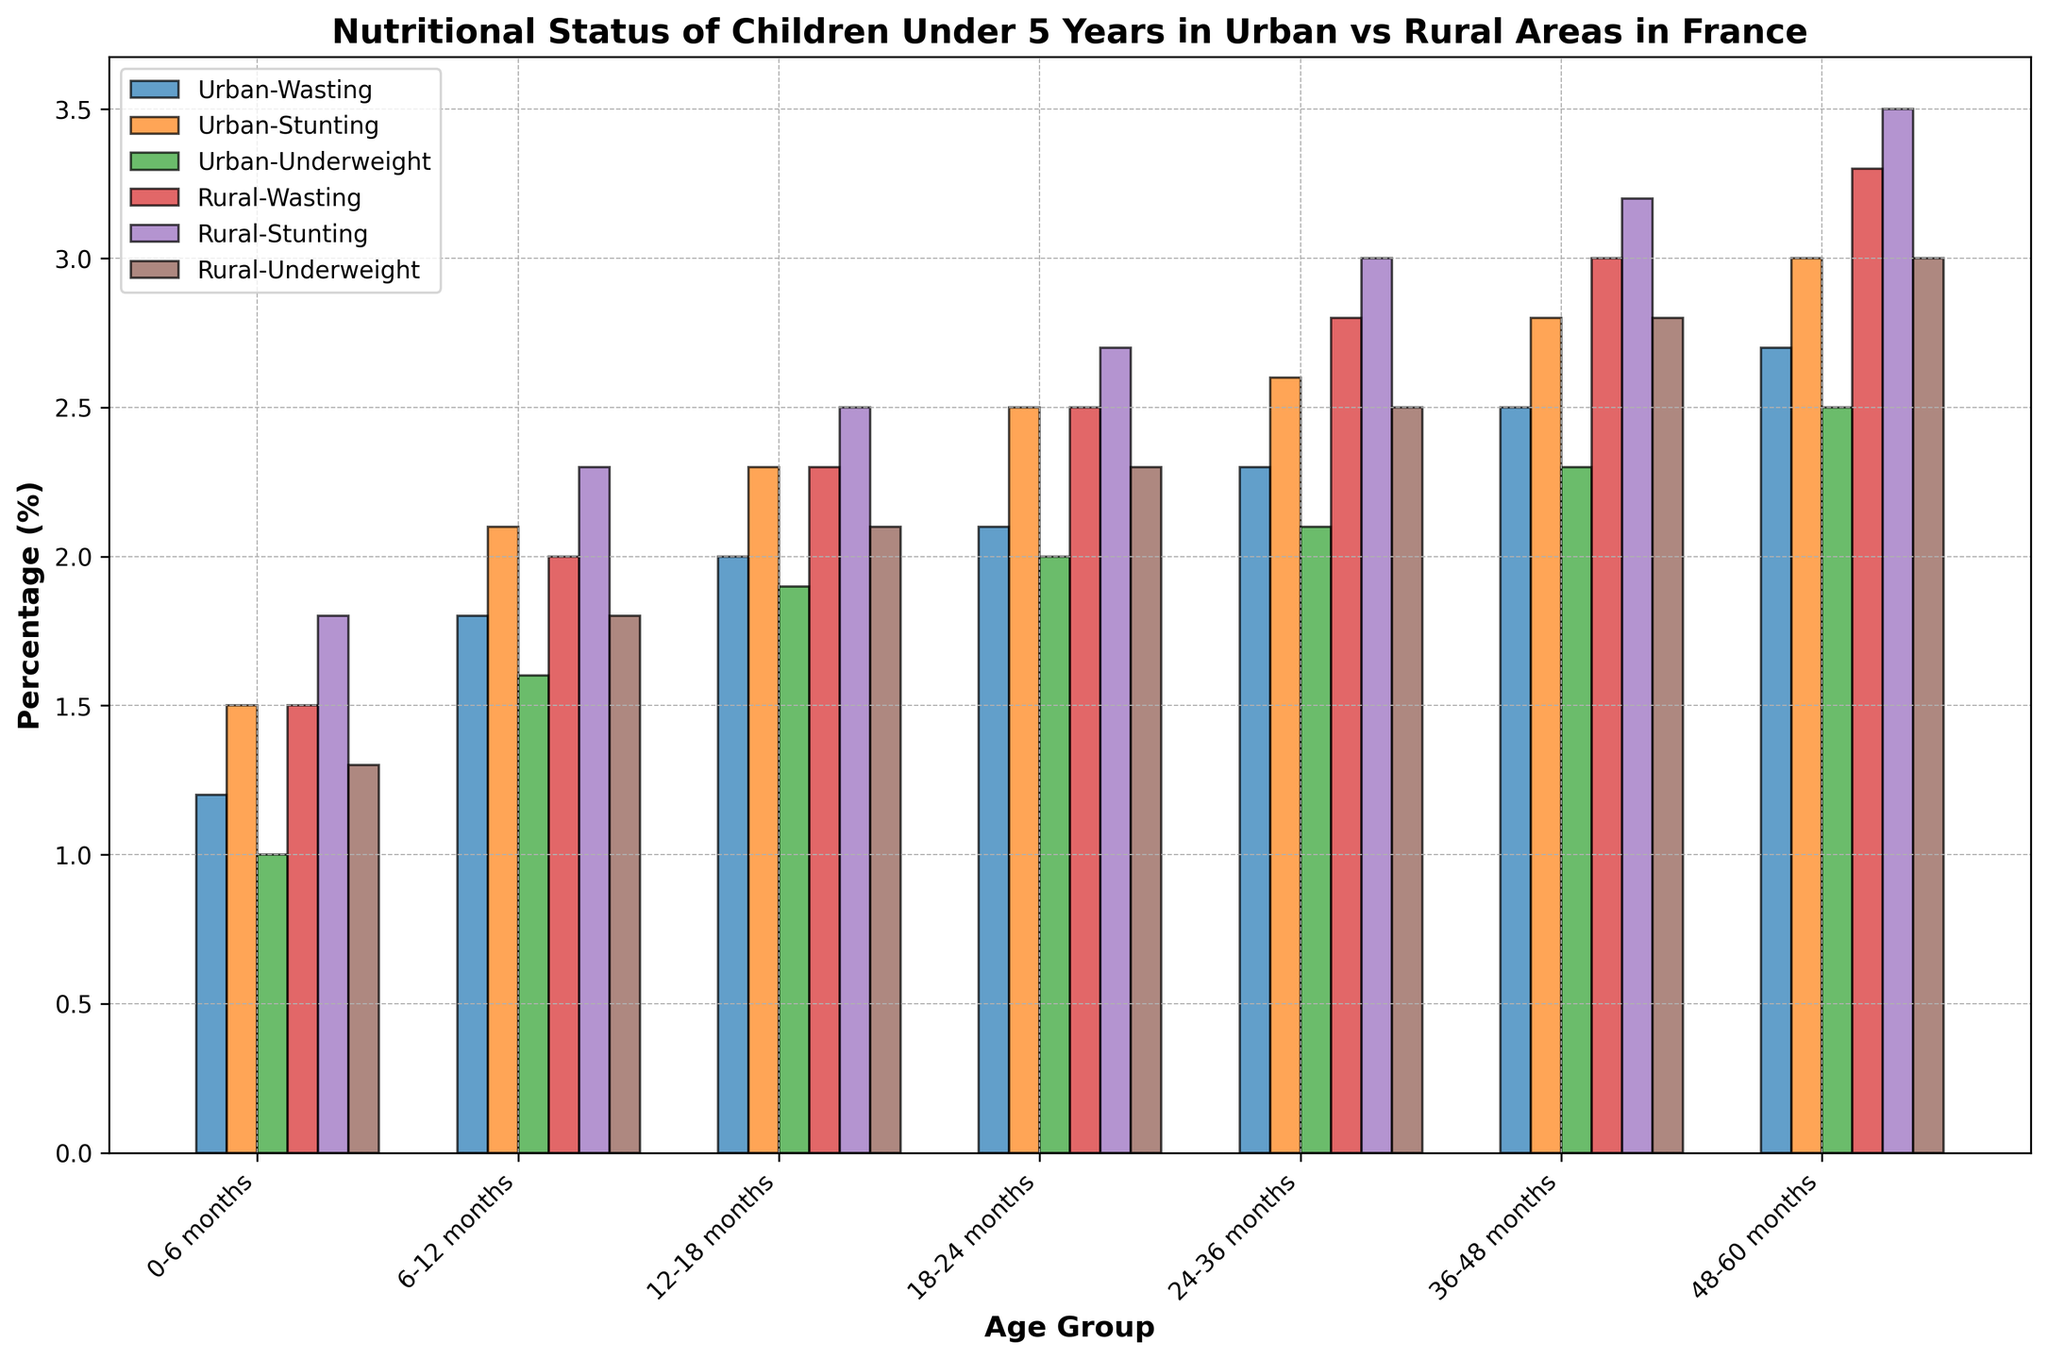what are the percentages of rural children experiencing wasting, stunting, and underweight in the age group of 48-60 months? First, locate the bars corresponding to rural children in the age group of 48-60 months. The percentages are 3.3% for wasting, 3.5% for stunting, and 3% for underweight.
Answer: 3.3%, 3.5%, 3% What is the percentage difference in stunting between urban and rural areas for the age group 36-48 months? Locate the bars for stunting in the 36-48 months age group for both urban and rural regions. The urban percentage is 2.8%, and the rural percentage is 3.2%. The difference is 3.2% - 2.8% = 0.4%.
Answer: 0.4% Which age group shows the highest percentage of wasting in rural areas? Identify the tallest bar representing wasting for rural areas across all age groups. The highest percentage of wasting is in the 48-60 months age group, which is 3.3%.
Answer: 48-60 months Considering the data for stunting, which region shows a higher percentage for children aged 24-36 months? Compare the bars representing stunting for the 24-36 months age group between urban and rural regions. The urban percentage is 2.6%, while the rural percentage is 3.0%. Therefore, rural areas show a higher percentage.
Answer: Rural Across all indicators and age groups, how do the nutritional statuses of children in urban areas overall compare to those in rural areas? Consider the average percentage for each indicator across all age groups for both regions. Urban areas consistently show lower percentages compared to rural areas, indicating better nutritional status.
Answer: Urban is better Which indicator shows the least difference between urban and rural areas in the age group 6-12 months? For the 6-12 months age group, compare wasting (urban 1.8%, rural 2.0% = 0.2% diff), stunting (urban 2.1%, rural 2.3% = 0.2% diff), and underweight (urban 1.6%, rural 1.8% = 0.2% diff). All indicators have the same difference of 0.2%.
Answer: All indicators have 0.2% diff In the age group 12-18 months, which indicator shows the highest percentage in rural areas? Locate the bars representing wasting, stunting, and underweight for rural children aged 12-18 months. Stunting has the highest percentage at 2.5%.
Answer: Stunting How does the percentage of underweight children in urban areas change from 0-6 months to 48-60 months? Identify the bars for underweight across the age groups in the urban region: 0-6 months (1.0%), 48-60 months (2.5%). Calculate the change: 2.5% - 1.0% = 1.5%.
Answer: Increases by 1.5% What is the overall trend for the percentage of stunting in rural areas as children age? Examine the bars for stunting in rural areas across all age groups. The percentage increases consistently from 1.8% (0-6 months) to 3.5% (48-60 months).
Answer: Increases 